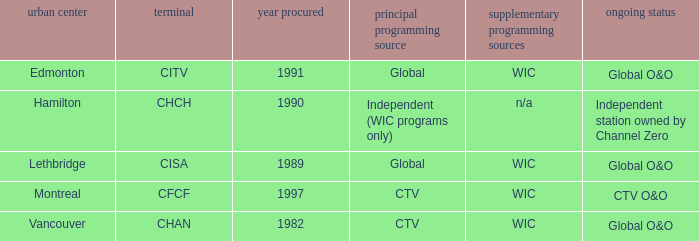Which station is located in edmonton CITV. 